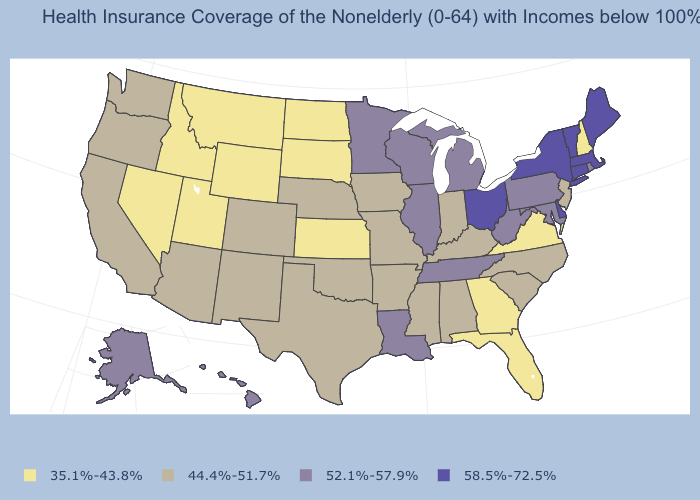Name the states that have a value in the range 35.1%-43.8%?
Be succinct. Florida, Georgia, Idaho, Kansas, Montana, Nevada, New Hampshire, North Dakota, South Dakota, Utah, Virginia, Wyoming. Which states have the highest value in the USA?
Write a very short answer. Connecticut, Delaware, Maine, Massachusetts, New York, Ohio, Vermont. What is the highest value in the West ?
Short answer required. 52.1%-57.9%. What is the value of Kansas?
Answer briefly. 35.1%-43.8%. Is the legend a continuous bar?
Be succinct. No. Name the states that have a value in the range 58.5%-72.5%?
Write a very short answer. Connecticut, Delaware, Maine, Massachusetts, New York, Ohio, Vermont. Does Missouri have a higher value than Maine?
Write a very short answer. No. Which states have the lowest value in the USA?
Write a very short answer. Florida, Georgia, Idaho, Kansas, Montana, Nevada, New Hampshire, North Dakota, South Dakota, Utah, Virginia, Wyoming. Which states have the lowest value in the South?
Quick response, please. Florida, Georgia, Virginia. Does Louisiana have the lowest value in the USA?
Be succinct. No. Name the states that have a value in the range 58.5%-72.5%?
Keep it brief. Connecticut, Delaware, Maine, Massachusetts, New York, Ohio, Vermont. What is the value of California?
Quick response, please. 44.4%-51.7%. What is the value of Kentucky?
Short answer required. 44.4%-51.7%. Does the first symbol in the legend represent the smallest category?
Quick response, please. Yes. What is the value of Wyoming?
Short answer required. 35.1%-43.8%. 